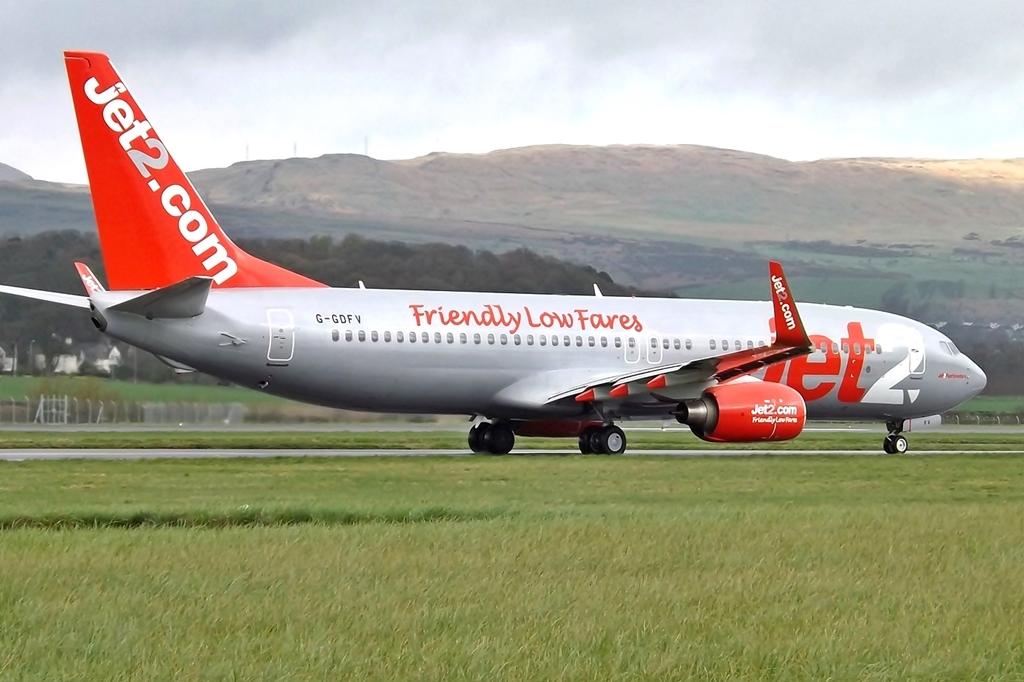What website is this jet associated with?
Give a very brief answer. Jet2.com. What does this jet advertise as having?
Your response must be concise. Friendly low fares. 